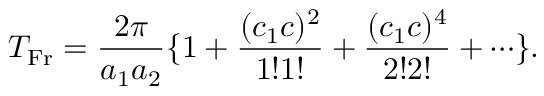<formula> <loc_0><loc_0><loc_500><loc_500>T _ { F r } = \frac { 2 \pi } { a _ { 1 } a _ { 2 } } \{ 1 + \frac { ( c _ { 1 } c ) ^ { 2 } } { 1 ! 1 ! } + \frac { ( c _ { 1 } c ) ^ { 4 } } { 2 ! 2 ! } + \cdots \} .</formula> 